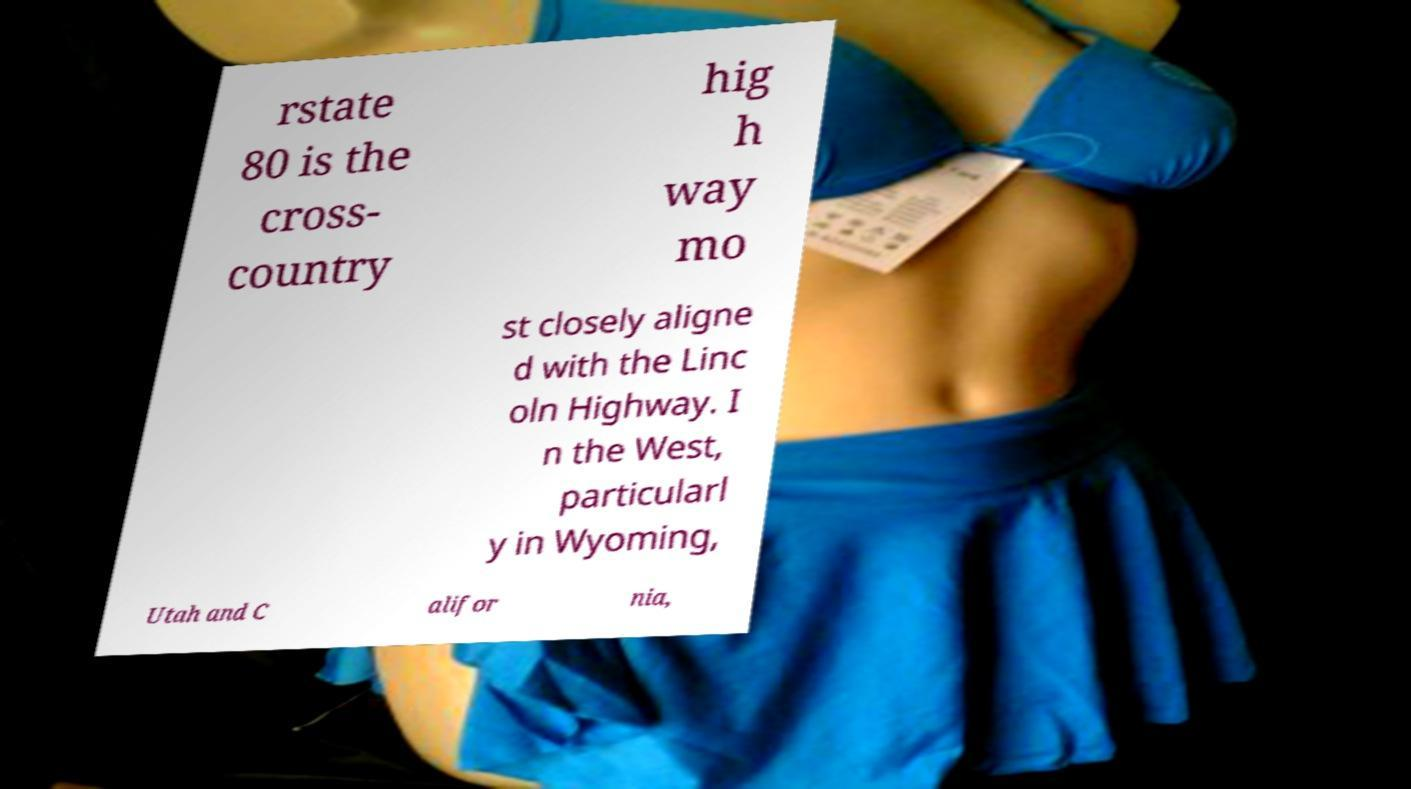Please identify and transcribe the text found in this image. rstate 80 is the cross- country hig h way mo st closely aligne d with the Linc oln Highway. I n the West, particularl y in Wyoming, Utah and C alifor nia, 